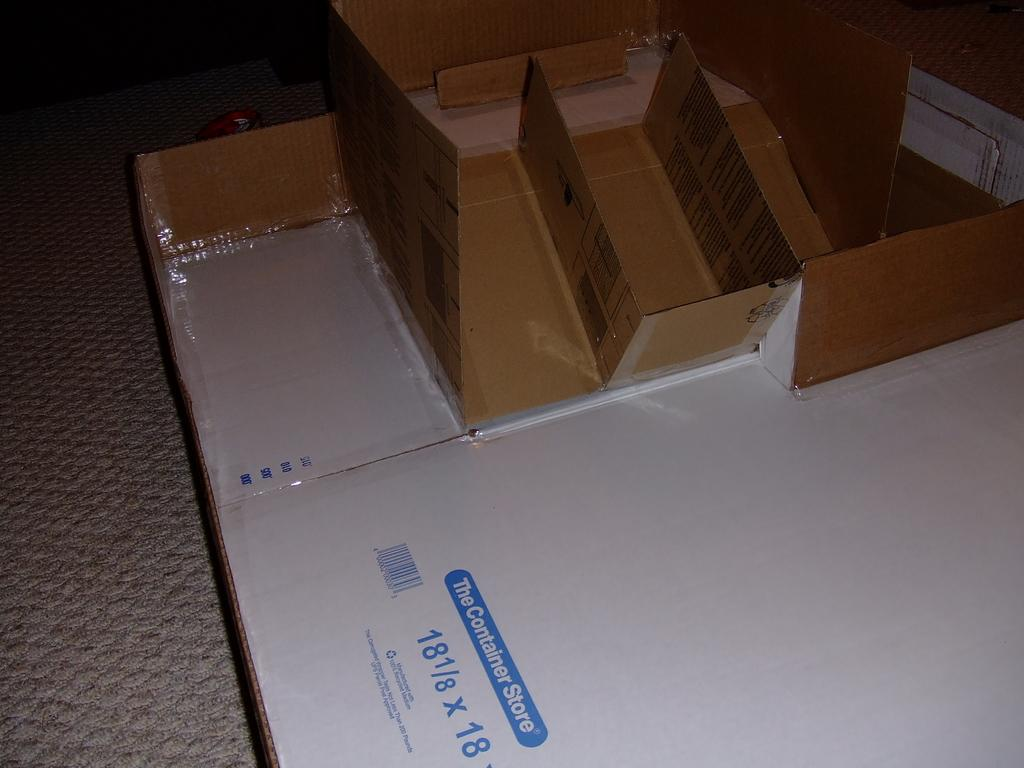Provide a one-sentence caption for the provided image. A box from the Container Store that is 18 1/8 x 18. 